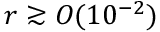Convert formula to latex. <formula><loc_0><loc_0><loc_500><loc_500>r \gtrsim O ( 1 0 ^ { - 2 } )</formula> 